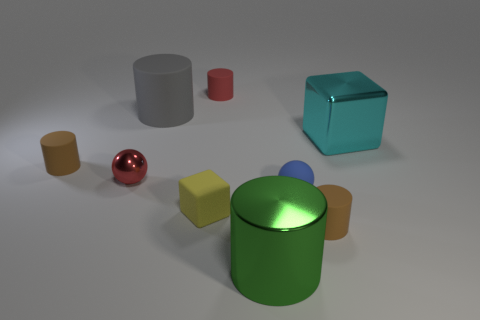Is the shape of the big green thing the same as the large gray rubber thing?
Your answer should be very brief. Yes. The red sphere has what size?
Your answer should be compact. Small. The large cylinder that is made of the same material as the small blue sphere is what color?
Your response must be concise. Gray. What number of shiny things have the same size as the green cylinder?
Your answer should be very brief. 1. Is the material of the large cyan object that is right of the tiny blue matte object the same as the tiny block?
Ensure brevity in your answer.  No. Is the number of brown cylinders that are to the right of the rubber ball less than the number of blue matte balls?
Your answer should be very brief. No. There is a metallic object on the left side of the yellow cube; what shape is it?
Your answer should be compact. Sphere. The red metallic object that is the same size as the yellow rubber thing is what shape?
Ensure brevity in your answer.  Sphere. Is there a brown thing of the same shape as the big green thing?
Your answer should be compact. Yes. Do the gray rubber thing that is on the left side of the green metallic cylinder and the small brown rubber object that is on the left side of the tiny blue rubber ball have the same shape?
Ensure brevity in your answer.  Yes. 